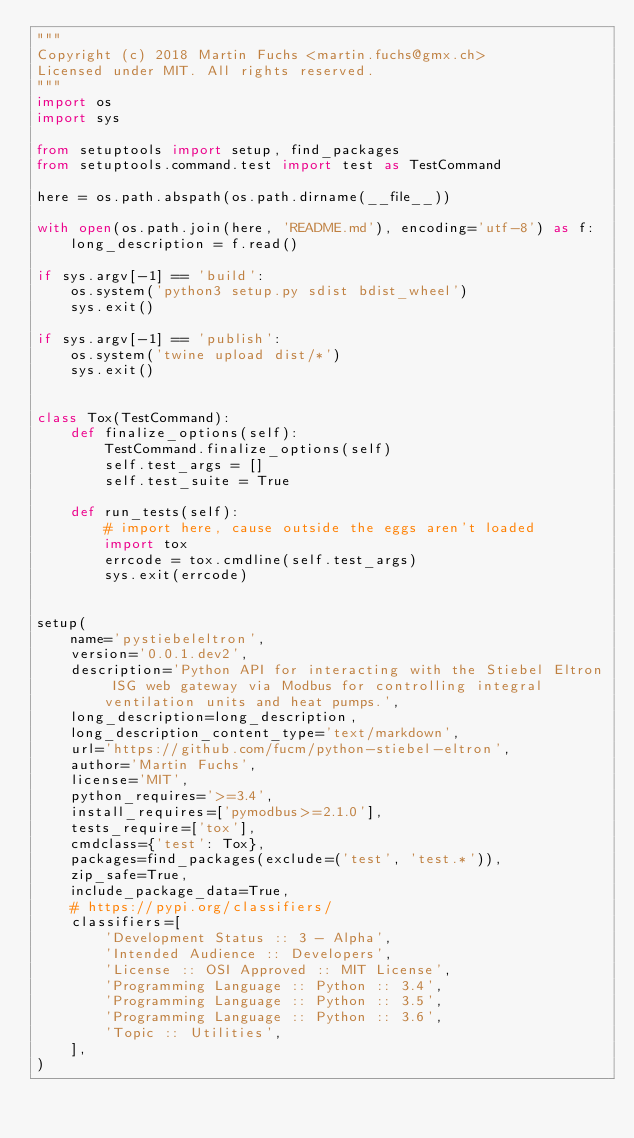<code> <loc_0><loc_0><loc_500><loc_500><_Python_>"""
Copyright (c) 2018 Martin Fuchs <martin.fuchs@gmx.ch>
Licensed under MIT. All rights reserved.
"""
import os
import sys

from setuptools import setup, find_packages
from setuptools.command.test import test as TestCommand

here = os.path.abspath(os.path.dirname(__file__))

with open(os.path.join(here, 'README.md'), encoding='utf-8') as f:
    long_description = f.read()

if sys.argv[-1] == 'build':
    os.system('python3 setup.py sdist bdist_wheel')
    sys.exit()

if sys.argv[-1] == 'publish':
    os.system('twine upload dist/*')
    sys.exit()


class Tox(TestCommand):
    def finalize_options(self):
        TestCommand.finalize_options(self)
        self.test_args = []
        self.test_suite = True

    def run_tests(self):
        # import here, cause outside the eggs aren't loaded
        import tox
        errcode = tox.cmdline(self.test_args)
        sys.exit(errcode)


setup(
    name='pystiebeleltron',
    version='0.0.1.dev2',
    description='Python API for interacting with the Stiebel Eltron ISG web gateway via Modbus for controlling integral ventilation units and heat pumps.',
    long_description=long_description,
    long_description_content_type='text/markdown',
    url='https://github.com/fucm/python-stiebel-eltron',
    author='Martin Fuchs',
    license='MIT',
    python_requires='>=3.4',
    install_requires=['pymodbus>=2.1.0'],
    tests_require=['tox'],
    cmdclass={'test': Tox},
    packages=find_packages(exclude=('test', 'test.*')),
    zip_safe=True,
    include_package_data=True,
    # https://pypi.org/classifiers/
    classifiers=[
        'Development Status :: 3 - Alpha',
        'Intended Audience :: Developers',
        'License :: OSI Approved :: MIT License',
        'Programming Language :: Python :: 3.4',
        'Programming Language :: Python :: 3.5',
        'Programming Language :: Python :: 3.6',
        'Topic :: Utilities',
    ],
)
</code> 